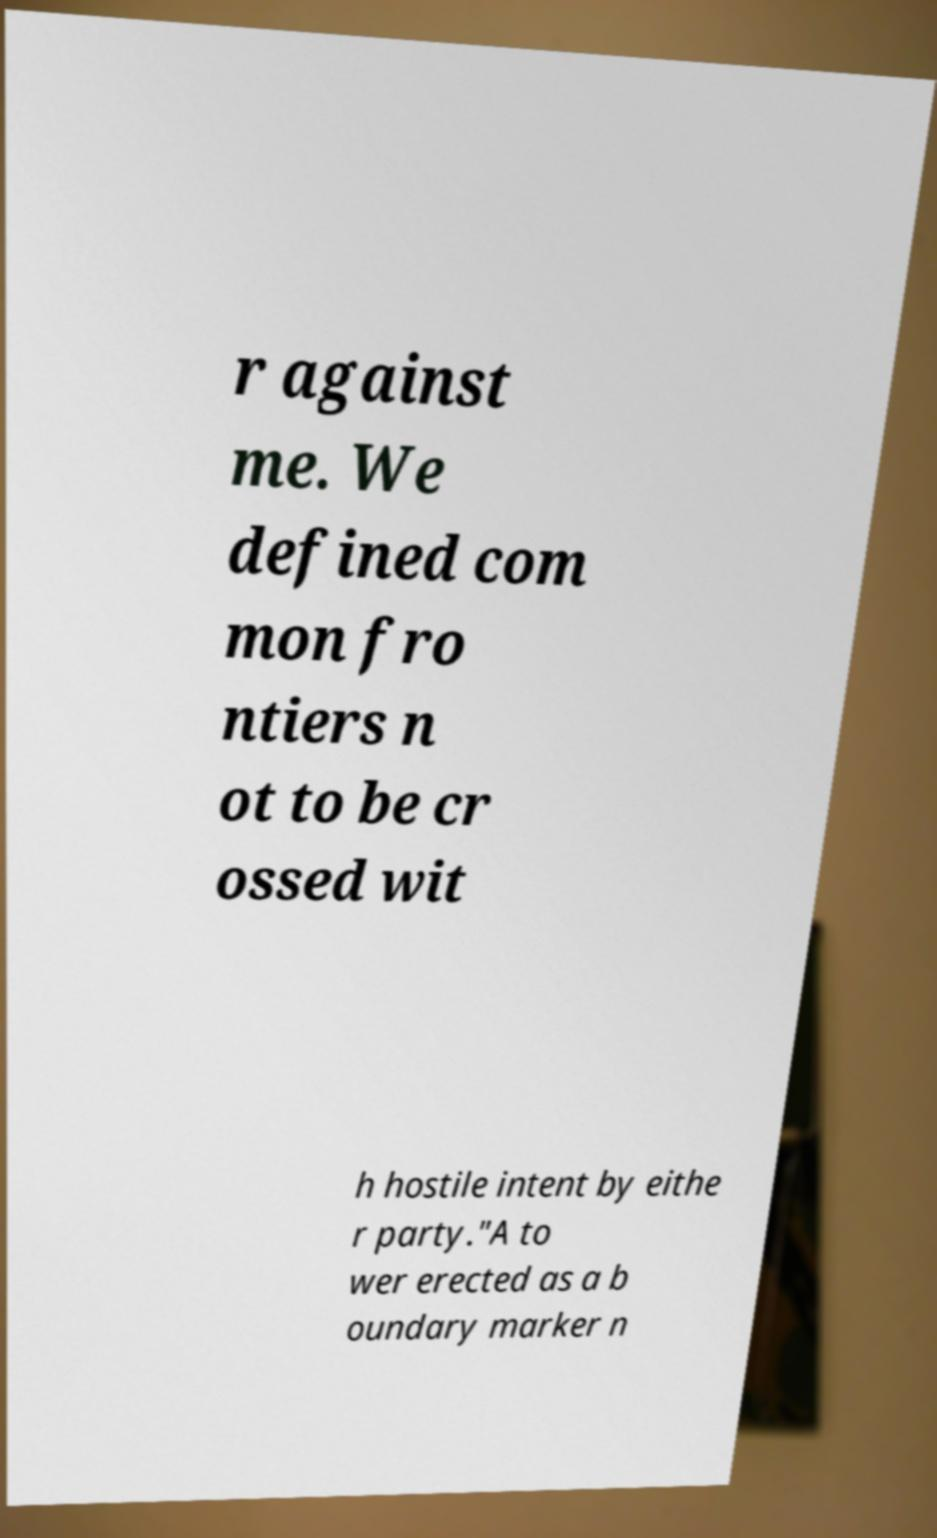For documentation purposes, I need the text within this image transcribed. Could you provide that? r against me. We defined com mon fro ntiers n ot to be cr ossed wit h hostile intent by eithe r party."A to wer erected as a b oundary marker n 